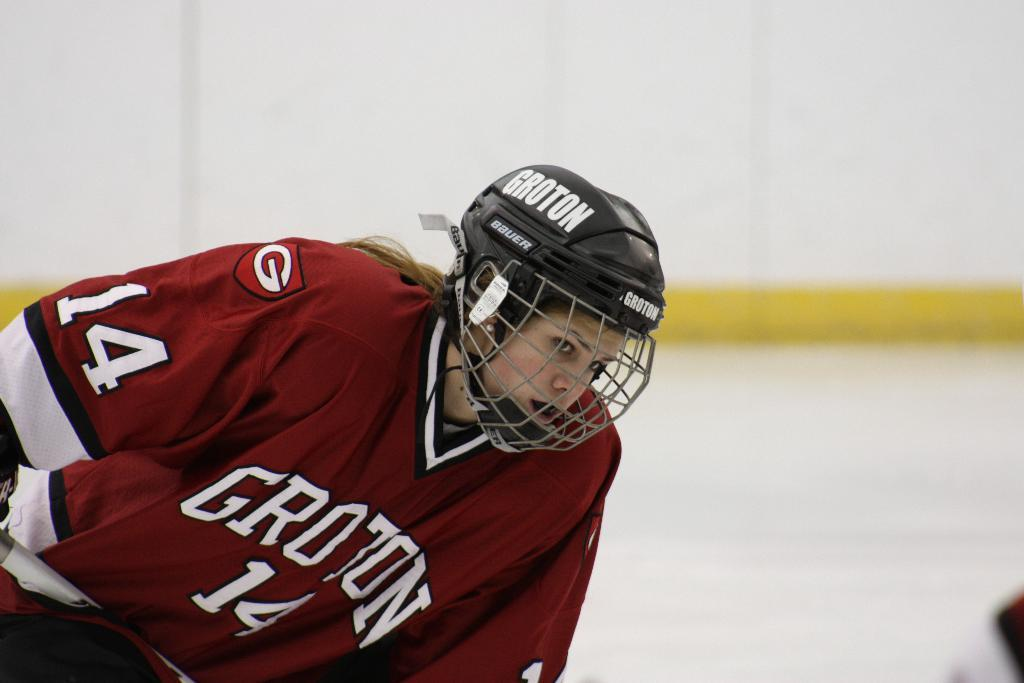Who or what is present in the image? There is a person in the image. What is the person wearing on their head? The person is wearing a helmet. What can be seen in the background of the image? There is a wall in the background of the image. What type of farm animal can be seen in the image? There is no farm animal present in the image; it features a person wearing a helmet with a wall in the background. What is the person doing to their throat in the image? There is no indication in the image that the person is doing anything to their throat. 